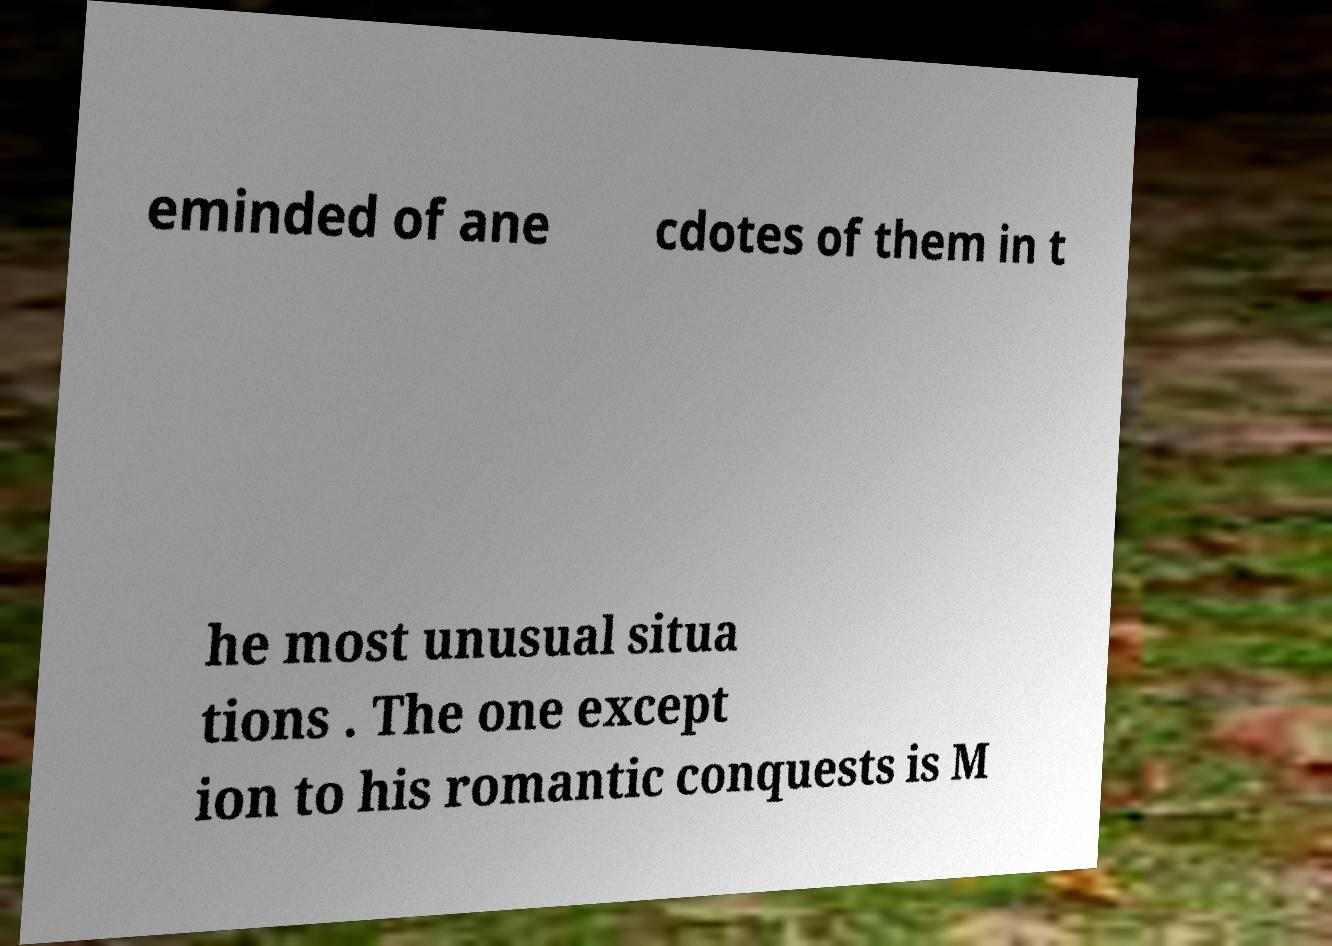There's text embedded in this image that I need extracted. Can you transcribe it verbatim? eminded of ane cdotes of them in t he most unusual situa tions . The one except ion to his romantic conquests is M 